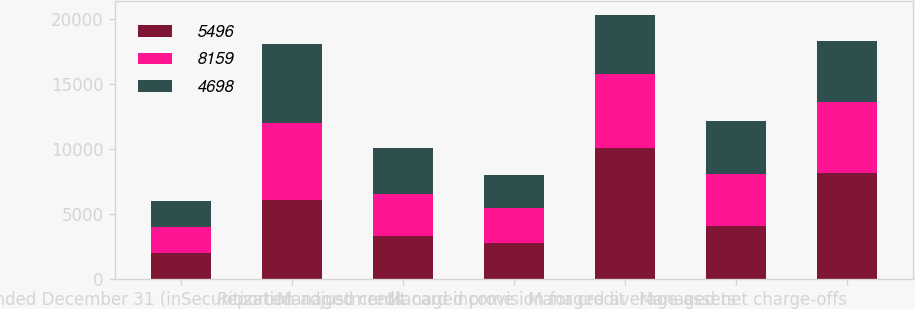Convert chart. <chart><loc_0><loc_0><loc_500><loc_500><stacked_bar_chart><ecel><fcel>Year ended December 31 (in<fcel>Reported<fcel>Securitization adjustments<fcel>Managed credit card income<fcel>Managed provision for credit<fcel>Managed average assets<fcel>Managed net charge-offs<nl><fcel>5496<fcel>2008<fcel>6082<fcel>3314<fcel>2768<fcel>10059<fcel>4053.5<fcel>8159<nl><fcel>8159<fcel>2007<fcel>5940<fcel>3255<fcel>2685<fcel>5711<fcel>4053.5<fcel>5496<nl><fcel>4698<fcel>2006<fcel>6096<fcel>3509<fcel>2587<fcel>4598<fcel>4053.5<fcel>4698<nl></chart> 